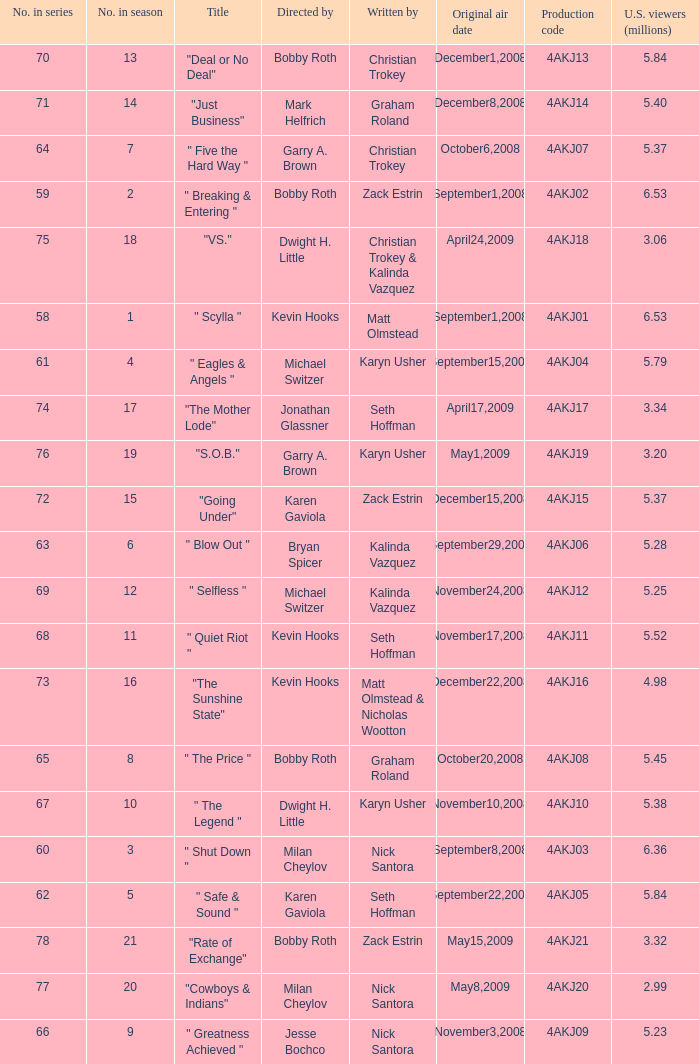Who directed the episode with production code 4akj01? Kevin Hooks. 